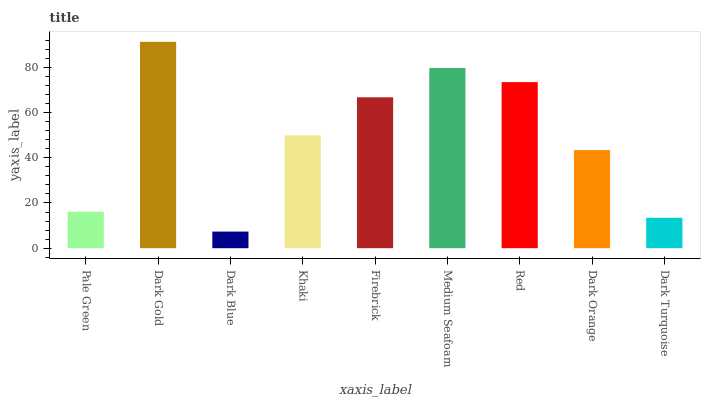Is Dark Gold the minimum?
Answer yes or no. No. Is Dark Blue the maximum?
Answer yes or no. No. Is Dark Gold greater than Dark Blue?
Answer yes or no. Yes. Is Dark Blue less than Dark Gold?
Answer yes or no. Yes. Is Dark Blue greater than Dark Gold?
Answer yes or no. No. Is Dark Gold less than Dark Blue?
Answer yes or no. No. Is Khaki the high median?
Answer yes or no. Yes. Is Khaki the low median?
Answer yes or no. Yes. Is Dark Gold the high median?
Answer yes or no. No. Is Pale Green the low median?
Answer yes or no. No. 